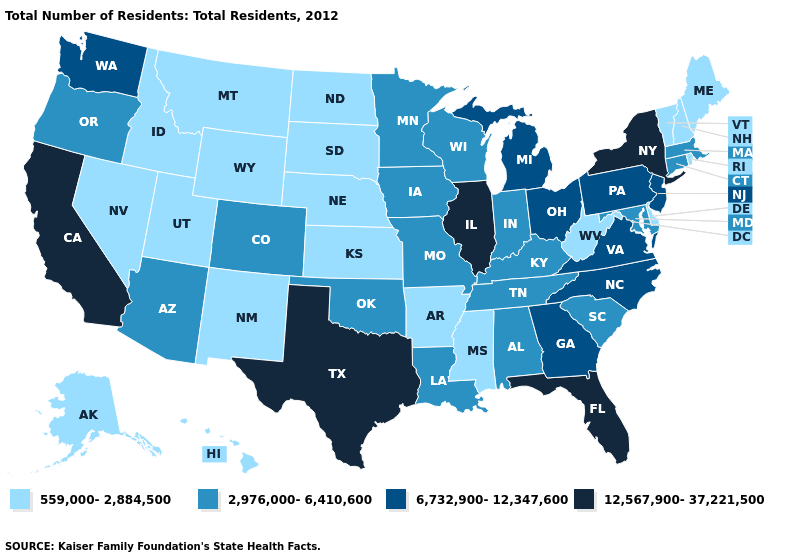Which states have the highest value in the USA?
Quick response, please. California, Florida, Illinois, New York, Texas. Does Maryland have the lowest value in the South?
Concise answer only. No. What is the lowest value in the USA?
Keep it brief. 559,000-2,884,500. What is the value of Vermont?
Answer briefly. 559,000-2,884,500. What is the value of South Carolina?
Concise answer only. 2,976,000-6,410,600. Name the states that have a value in the range 12,567,900-37,221,500?
Give a very brief answer. California, Florida, Illinois, New York, Texas. Which states hav the highest value in the Northeast?
Short answer required. New York. Name the states that have a value in the range 559,000-2,884,500?
Be succinct. Alaska, Arkansas, Delaware, Hawaii, Idaho, Kansas, Maine, Mississippi, Montana, Nebraska, Nevada, New Hampshire, New Mexico, North Dakota, Rhode Island, South Dakota, Utah, Vermont, West Virginia, Wyoming. Among the states that border New York , which have the lowest value?
Short answer required. Vermont. What is the lowest value in states that border South Dakota?
Short answer required. 559,000-2,884,500. Name the states that have a value in the range 12,567,900-37,221,500?
Quick response, please. California, Florida, Illinois, New York, Texas. What is the value of Arizona?
Write a very short answer. 2,976,000-6,410,600. Does Georgia have a lower value than Washington?
Quick response, please. No. What is the value of Arkansas?
Answer briefly. 559,000-2,884,500. Among the states that border West Virginia , which have the highest value?
Concise answer only. Ohio, Pennsylvania, Virginia. 